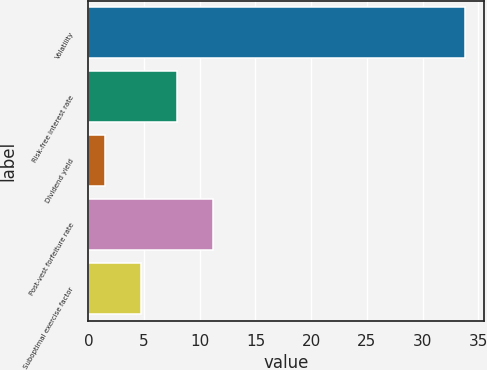Convert chart to OTSL. <chart><loc_0><loc_0><loc_500><loc_500><bar_chart><fcel>Volatility<fcel>Risk-free interest rate<fcel>Dividend yield<fcel>Post-vest forfeiture rate<fcel>Suboptimal exercise factor<nl><fcel>33.8<fcel>7.96<fcel>1.5<fcel>11.19<fcel>4.73<nl></chart> 